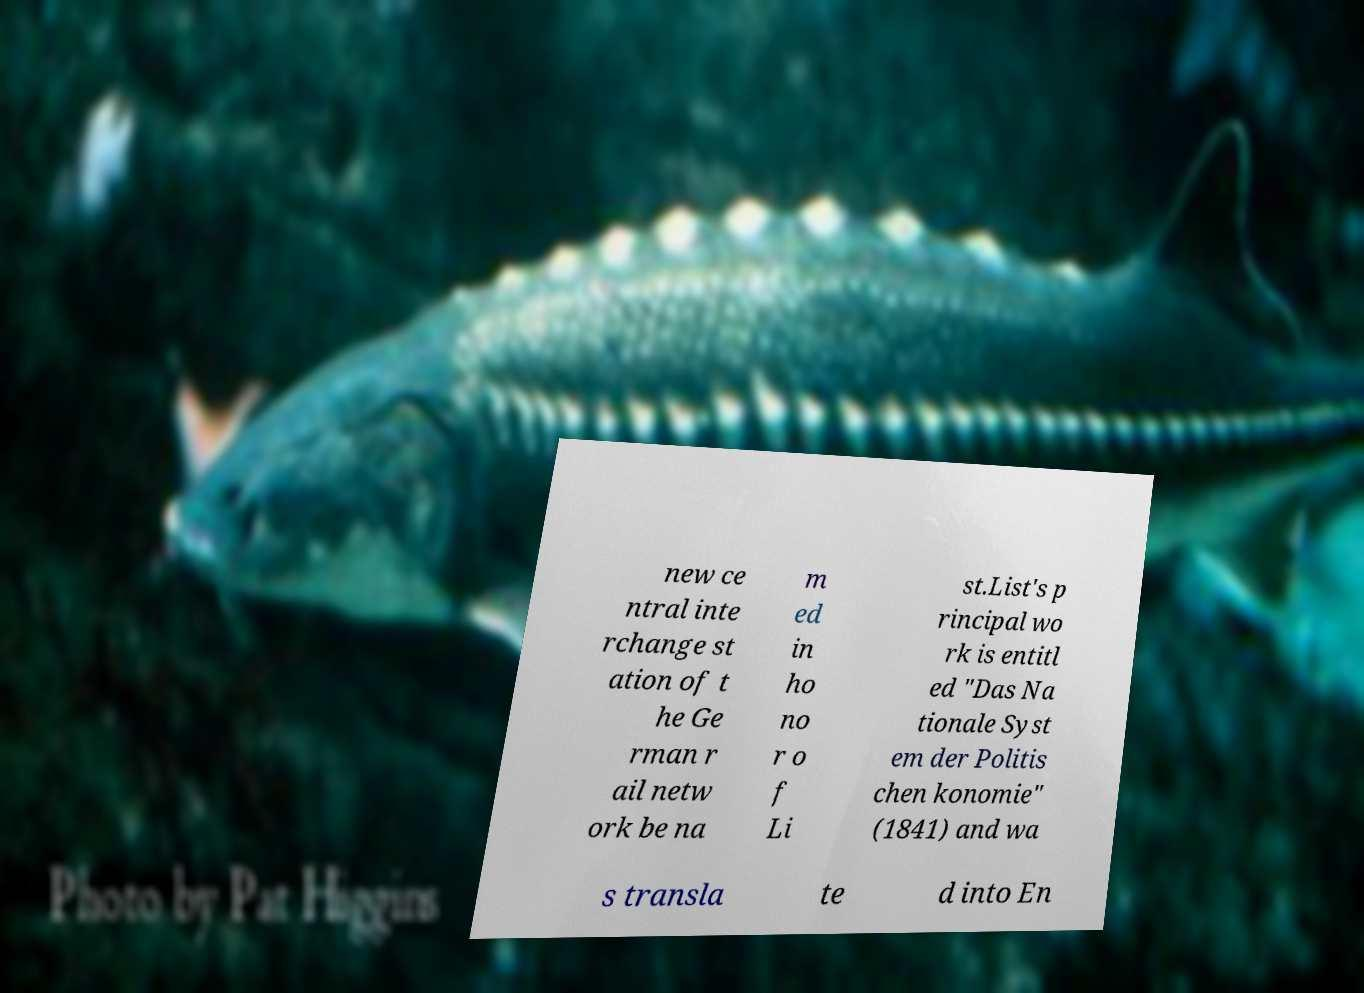Could you assist in decoding the text presented in this image and type it out clearly? new ce ntral inte rchange st ation of t he Ge rman r ail netw ork be na m ed in ho no r o f Li st.List's p rincipal wo rk is entitl ed "Das Na tionale Syst em der Politis chen konomie" (1841) and wa s transla te d into En 